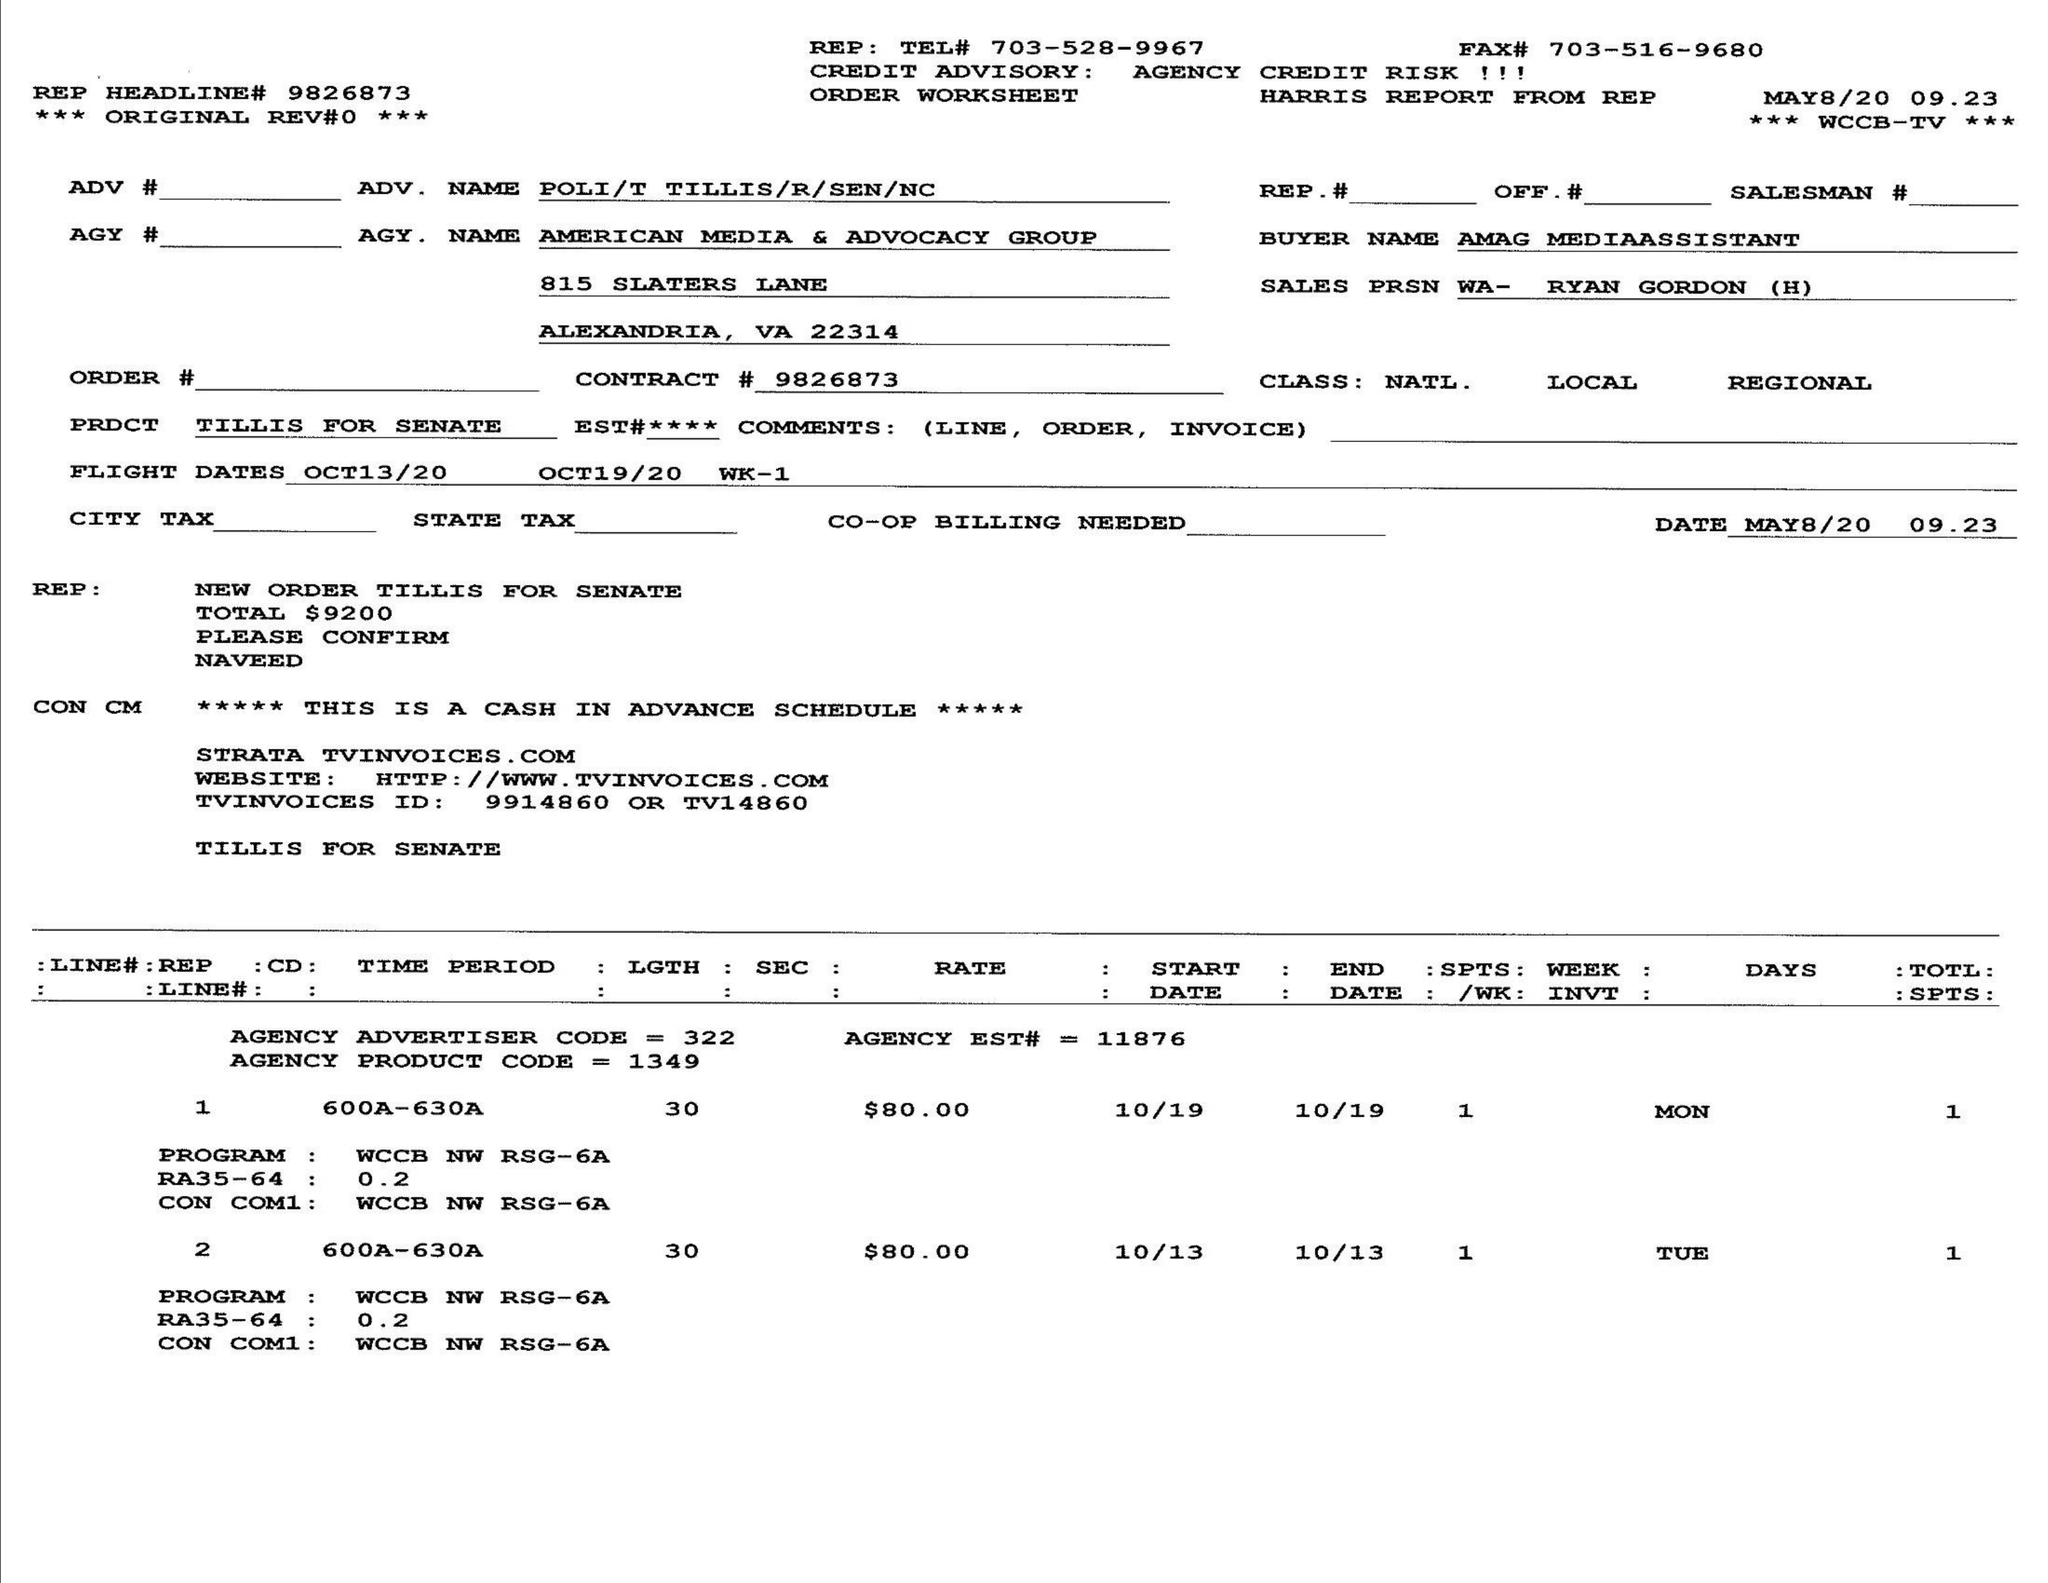What is the value for the flight_from?
Answer the question using a single word or phrase. 10/13/20 